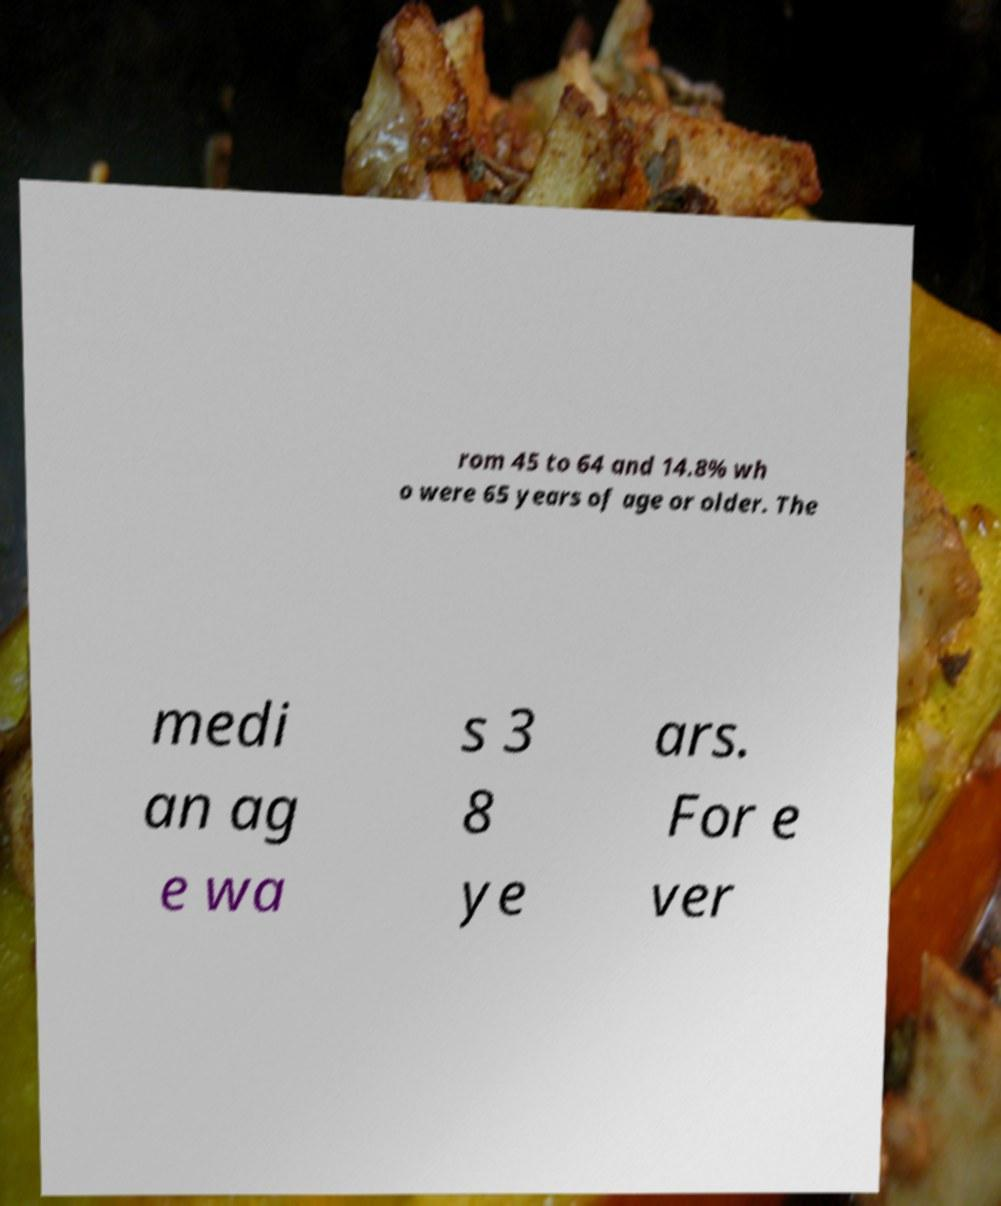Could you extract and type out the text from this image? rom 45 to 64 and 14.8% wh o were 65 years of age or older. The medi an ag e wa s 3 8 ye ars. For e ver 